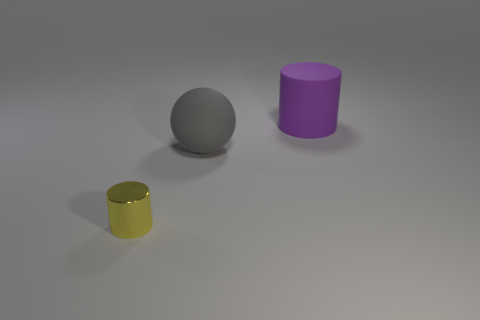What materials appear to be used for the objects in the image? The objects seem to be made from different materials. The sphere appears to have a matte metallic or plastic finish, possibly metal. The yellow cylinder looks metallic with a shiny surface, indicating it could be either metal or a polished plastic. The purple cylinder seems to have a matte finish, likely rubber or a matte plastic. 